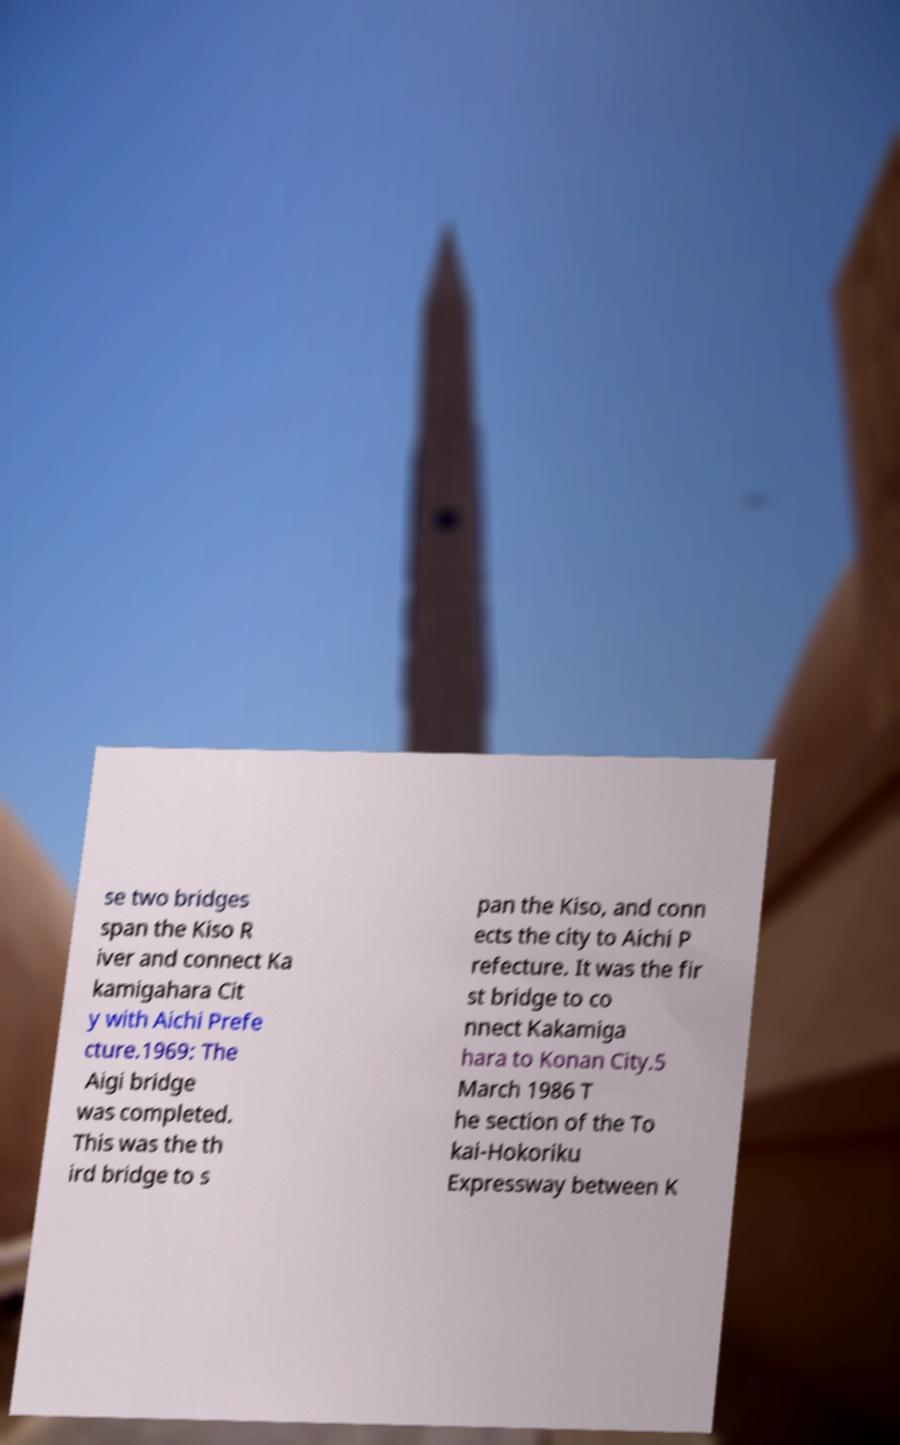Please read and relay the text visible in this image. What does it say? se two bridges span the Kiso R iver and connect Ka kamigahara Cit y with Aichi Prefe cture.1969: The Aigi bridge was completed. This was the th ird bridge to s pan the Kiso, and conn ects the city to Aichi P refecture. It was the fir st bridge to co nnect Kakamiga hara to Konan City.5 March 1986 T he section of the To kai-Hokoriku Expressway between K 